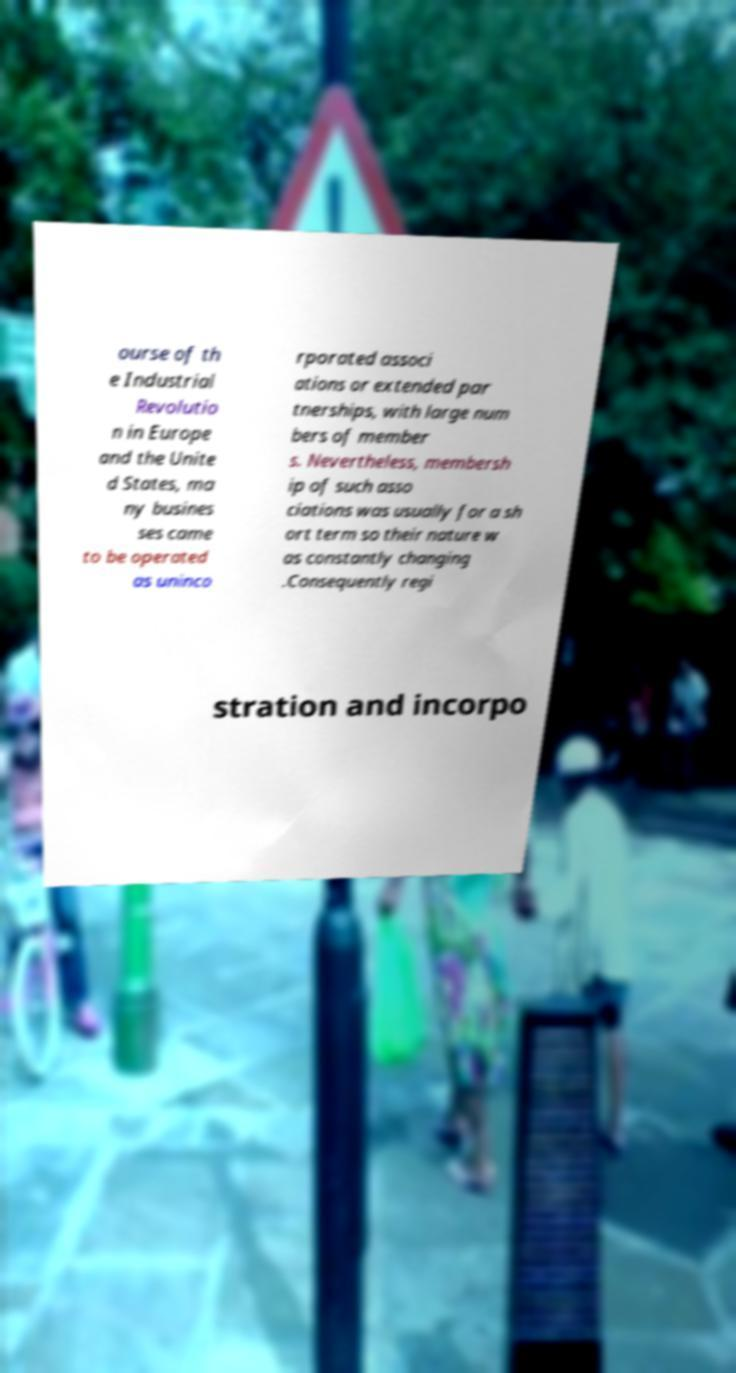Please read and relay the text visible in this image. What does it say? ourse of th e Industrial Revolutio n in Europe and the Unite d States, ma ny busines ses came to be operated as uninco rporated associ ations or extended par tnerships, with large num bers of member s. Nevertheless, membersh ip of such asso ciations was usually for a sh ort term so their nature w as constantly changing .Consequently regi stration and incorpo 